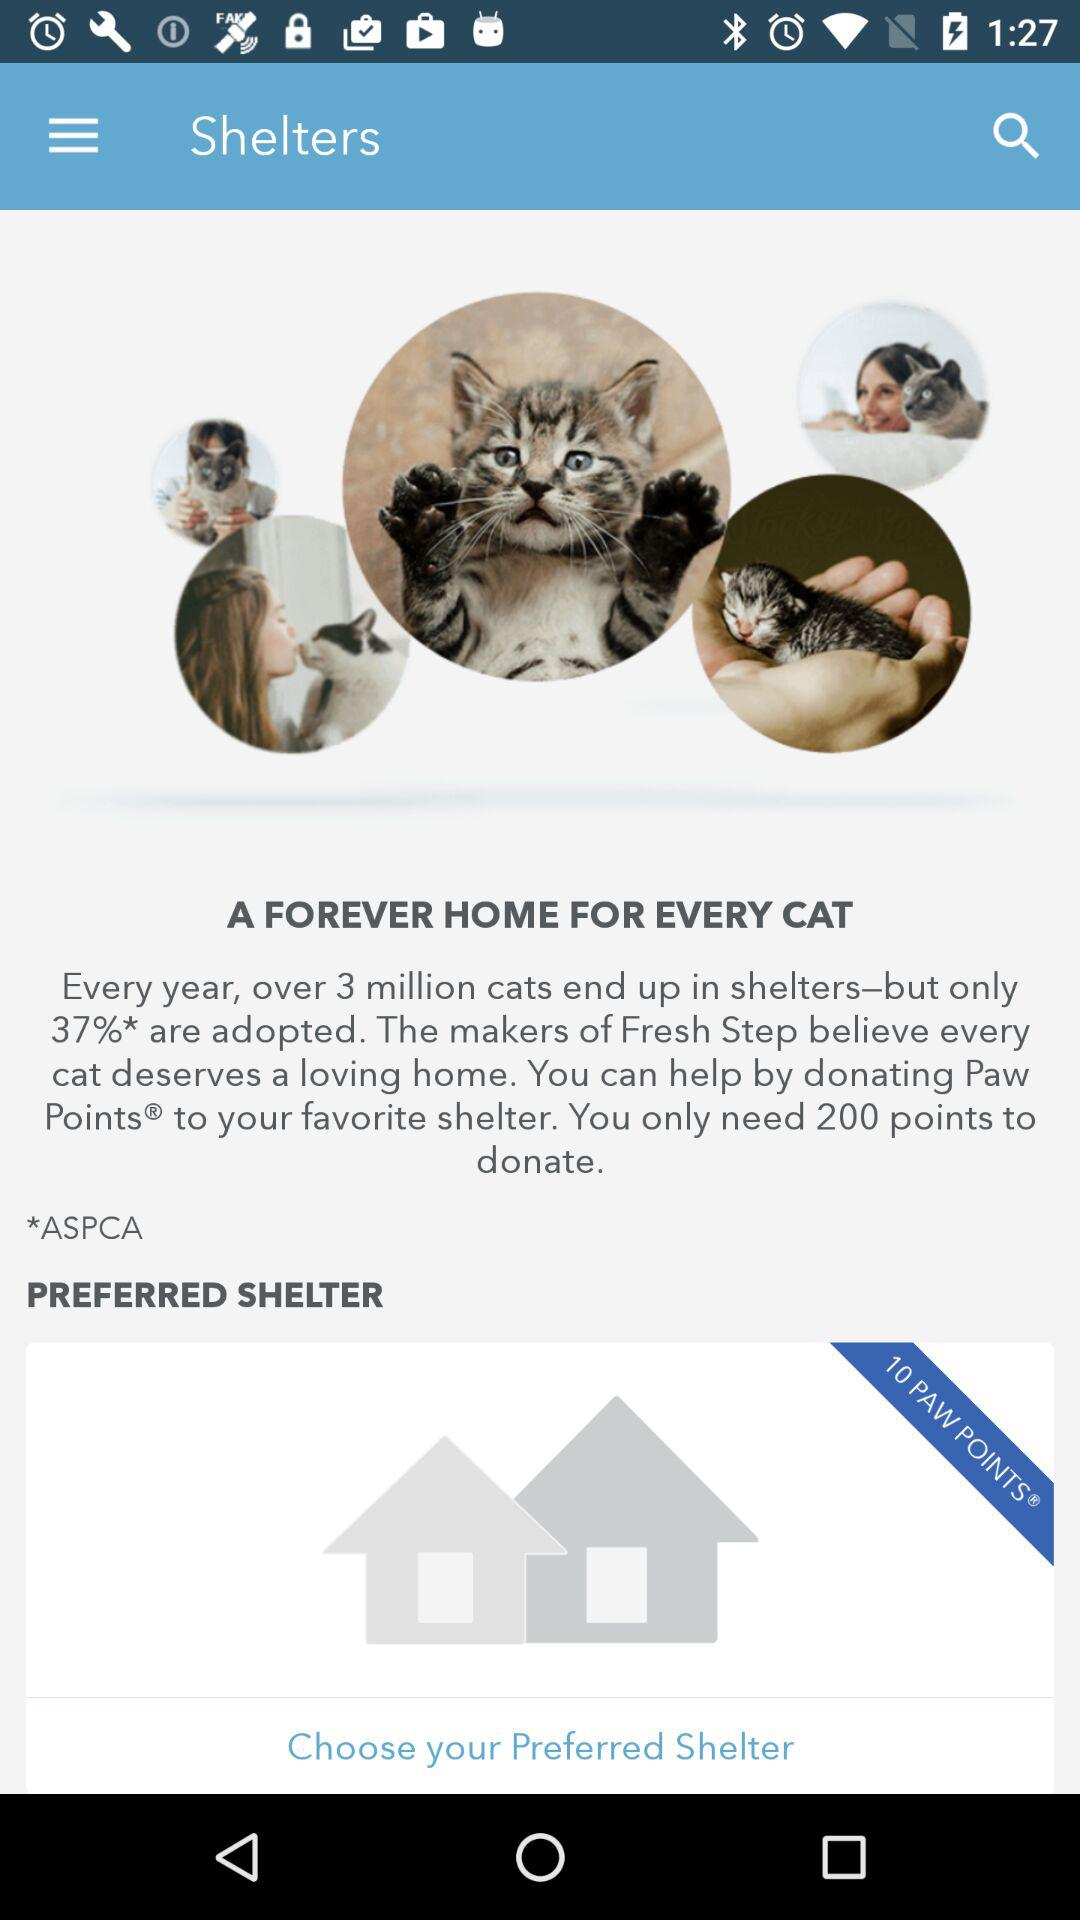How many points are we required to donate? You need 200 points to donate. 